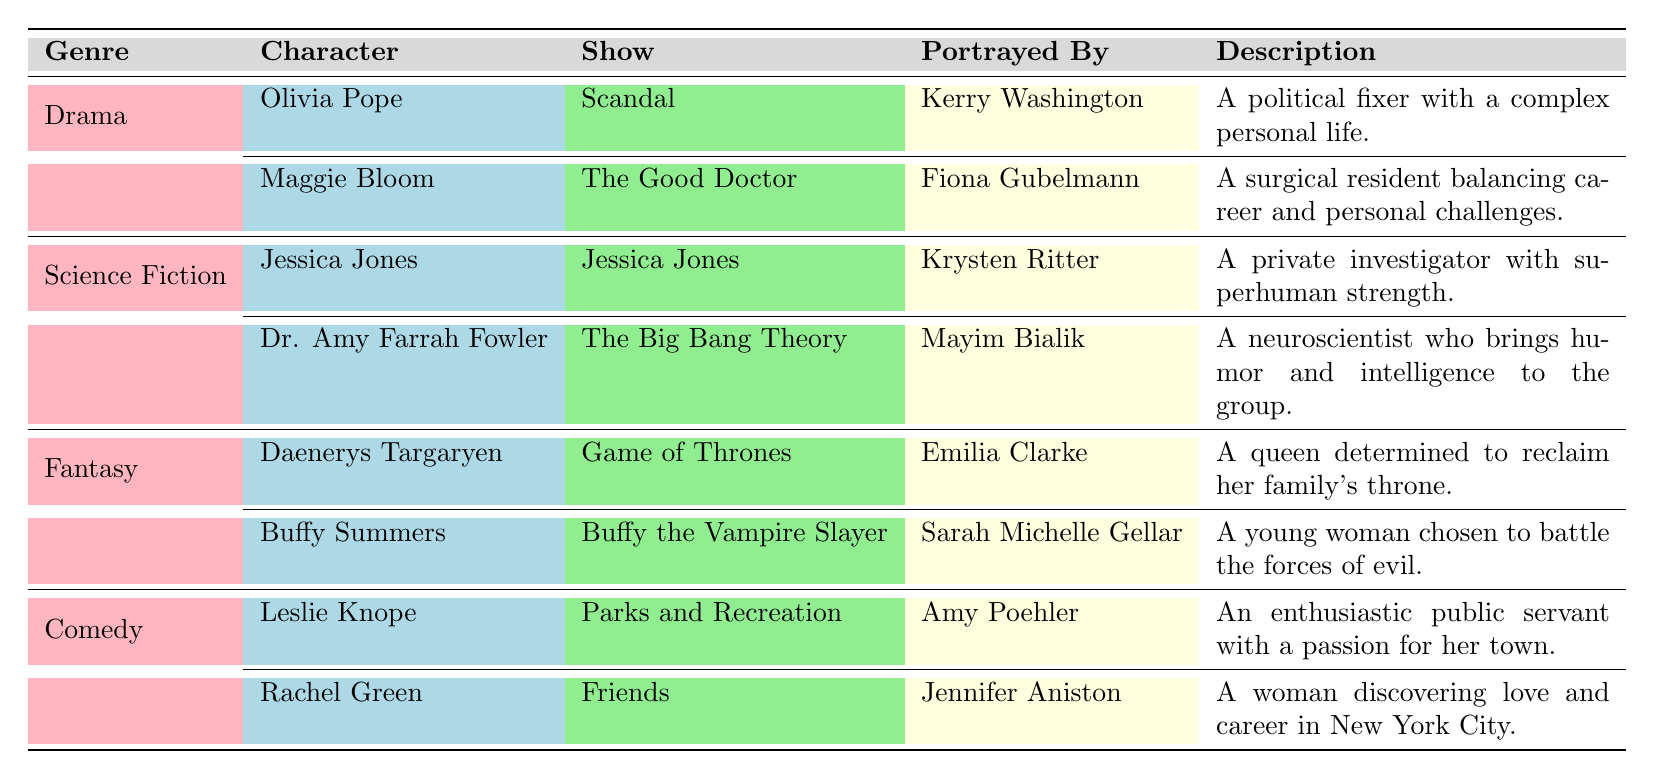What character is portrayed by Kerry Washington? According to the table, Kerry Washington portrays Olivia Pope in the show Scandal.
Answer: Olivia Pope Which genre features both a character named Buffy Summers and a character named Daenerys Targaryen? The table indicates that both Buffy Summers and Daenerys Targaryen belong to the genre Fantasy.
Answer: Fantasy True or False: Jessica Jones is a character in a Comedy show. The table lists Jessica Jones under the Science Fiction genre, indicating that this statement is false.
Answer: False What is the name of the show in which Maggie Bloom appears? The table shows that Maggie Bloom appears in the show The Good Doctor.
Answer: The Good Doctor Which character is a surgical resident? The table identifies Maggie Bloom as a surgical resident in The Good Doctor.
Answer: Maggie Bloom How many characters are listed in the Drama genre? The table provides information that there are two characters in the Drama genre: Olivia Pope and Maggie Bloom. Thus, the total is 2.
Answer: 2 Which character has superhuman strength? The table states that Jessica Jones, from the show Jessica Jones, possesses superhuman strength.
Answer: Jessica Jones What is the main theme for Leslie Knope's character? According to the table, Leslie Knope is described as an enthusiastic public servant with a passion for her town, indicating her focus on public service and community.
Answer: Public service What are the two shows featuring characters portrayed by actresses named Sarah and Mayim? The table shows Sarah Michelle Gellar portrays Buffy Summers in Buffy the Vampire Slayer, and Mayim Bialik portrays Dr. Amy Farrah Fowler in The Big Bang Theory. Therefore, the shows are Buffy the Vampire Slayer and The Big Bang Theory.
Answer: Buffy the Vampire Slayer, The Big Bang Theory 